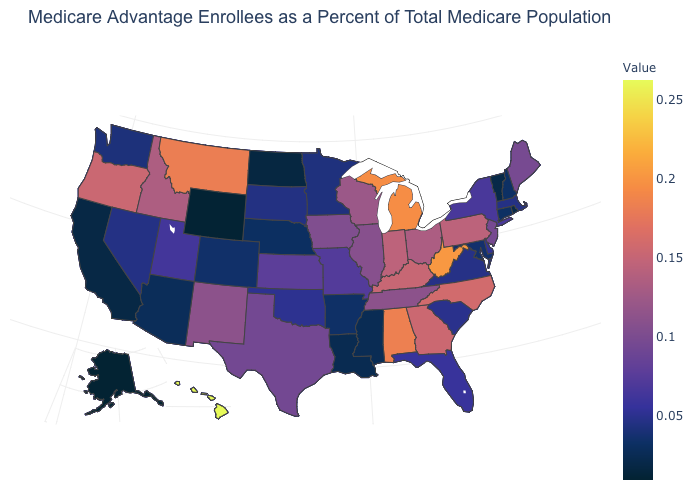Is the legend a continuous bar?
Be succinct. Yes. Among the states that border Nevada , does California have the lowest value?
Be succinct. Yes. Among the states that border Rhode Island , which have the lowest value?
Short answer required. Connecticut. 